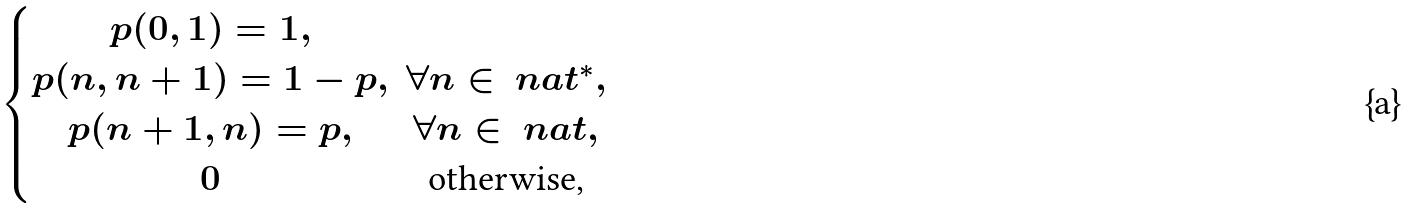Convert formula to latex. <formula><loc_0><loc_0><loc_500><loc_500>\begin{cases} \begin{matrix} p ( 0 , 1 ) = 1 , & \\ p ( n , n + 1 ) = 1 - p , & \forall n \in \ n a t ^ { * } , \\ p ( n + 1 , n ) = p , & \forall n \in \ n a t , \\ 0 & \text {otherwise,} \\ \end{matrix} \end{cases}</formula> 